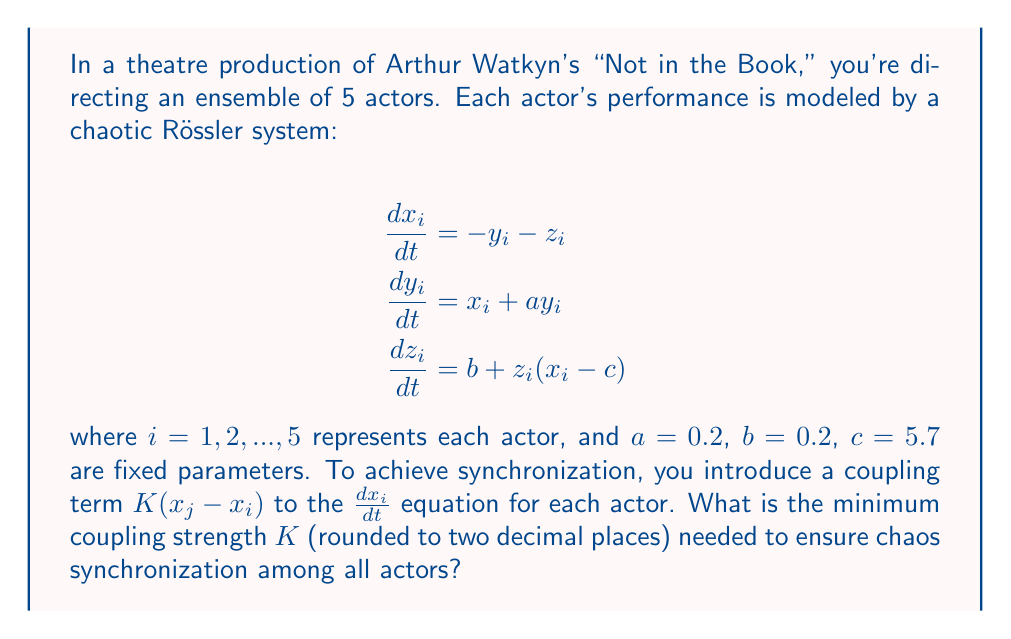What is the answer to this math problem? To solve this problem, we need to follow these steps:

1) First, we need to understand that chaos synchronization occurs when the difference between the states of any two systems approaches zero over time.

2) For the Rössler system, the Master Stability Function (MSF) approach can be used to determine the synchronization threshold.

3) The MSF for the Rössler system is given by:

   $$\lambda_{\text{max}} = \alpha - K\beta$$

   where $\lambda_{\text{max}}$ is the maximum Lyapunov exponent, $\alpha$ is the Lyapunov exponent of the uncoupled system, and $\beta$ is the eigenvalue of the coupling matrix.

4) For the Rössler system with the given parameters, $\alpha \approx 0.13$.

5) The coupling matrix for a fully connected network of 5 actors is:

   $$\begin{bmatrix}
   -4 & 1 & 1 & 1 & 1 \\
   1 & -4 & 1 & 1 & 1 \\
   1 & 1 & -4 & 1 & 1 \\
   1 & 1 & 1 & -4 & 1 \\
   1 & 1 & 1 & 1 & -4
   \end{bmatrix}$$

6) The eigenvalues of this matrix are $\{0, -5, -5, -5, -5\}$.

7) The smallest non-zero eigenvalue in magnitude is $\beta = 5$.

8) For synchronization, we need $\lambda_{\text{max}} < 0$. Therefore:

   $$0.13 - 5K < 0$$

9) Solving this inequality:

   $$5K > 0.13$$
   $$K > 0.026$$

10) Rounding to two decimal places, the minimum coupling strength needed is 0.03.
Answer: 0.03 